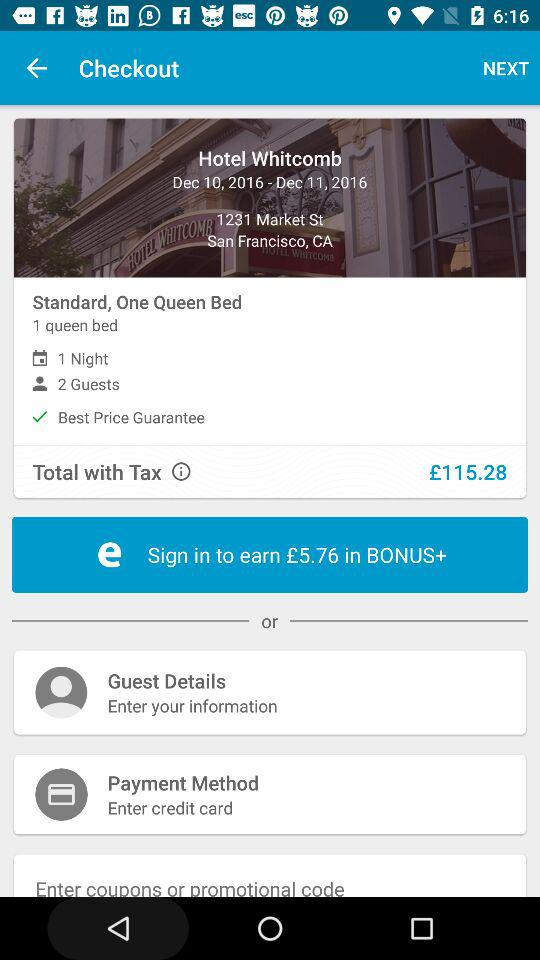Which tab is currently selected? The selected tab is "SHOP". 